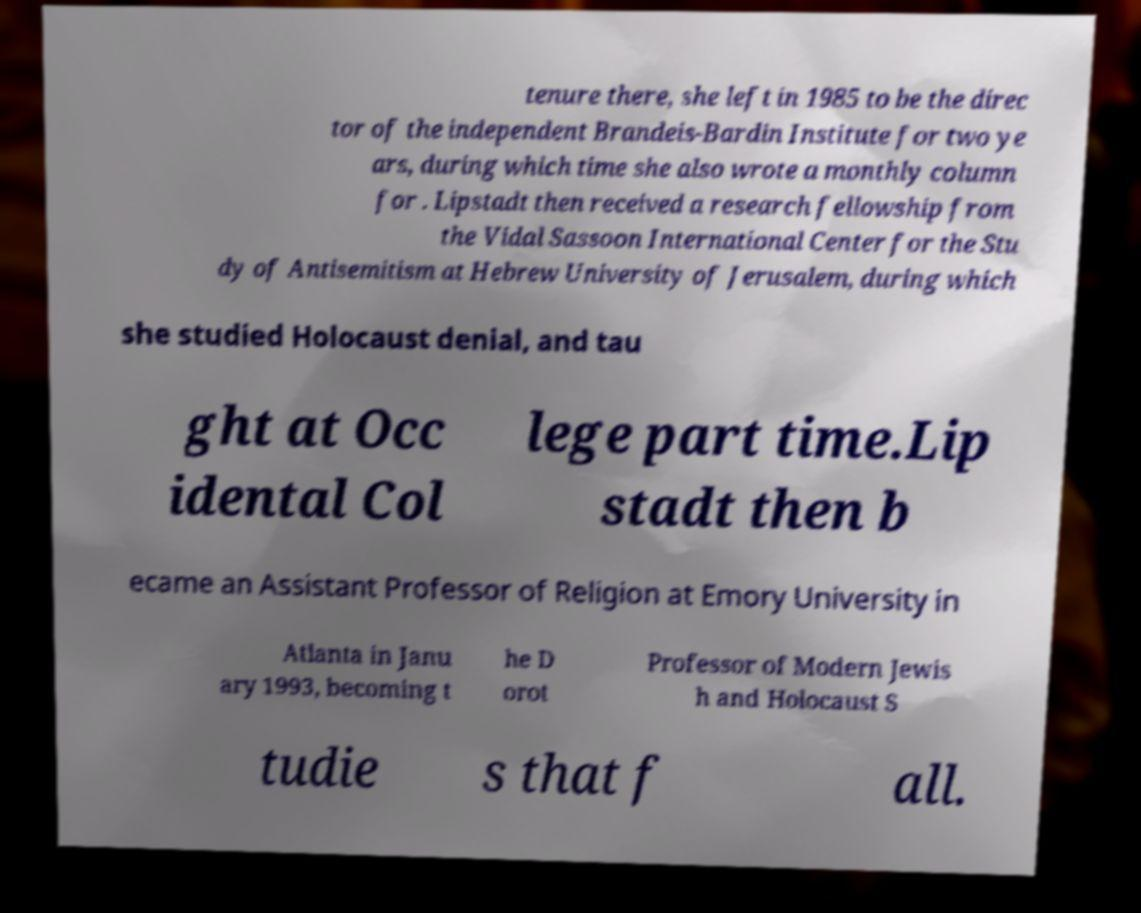Could you assist in decoding the text presented in this image and type it out clearly? tenure there, she left in 1985 to be the direc tor of the independent Brandeis-Bardin Institute for two ye ars, during which time she also wrote a monthly column for . Lipstadt then received a research fellowship from the Vidal Sassoon International Center for the Stu dy of Antisemitism at Hebrew University of Jerusalem, during which she studied Holocaust denial, and tau ght at Occ idental Col lege part time.Lip stadt then b ecame an Assistant Professor of Religion at Emory University in Atlanta in Janu ary 1993, becoming t he D orot Professor of Modern Jewis h and Holocaust S tudie s that f all. 